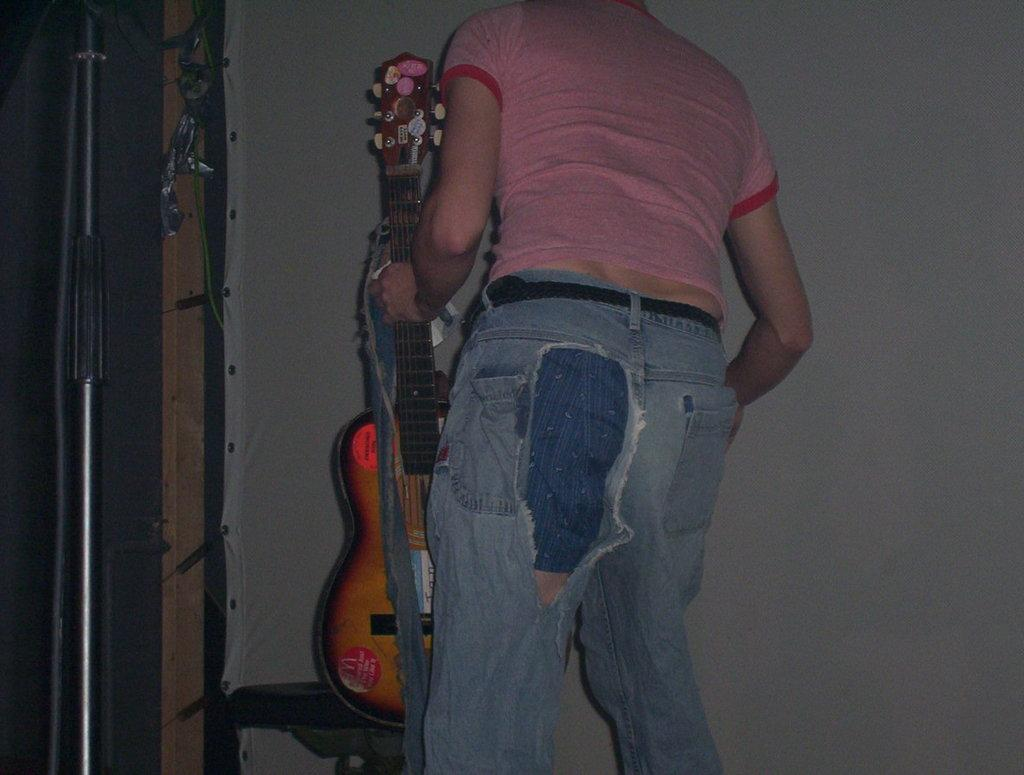What is the person in the image doing? The person is standing and holding a guitar. What object can be seen near the person? There is a pole in the image. What additional feature is present in the image? There is a white banner in the image. What type of suggestion is being made by the police in the image? There is no police presence or suggestion being made in the image; it only features a person holding a guitar, a pole, and a white banner. 